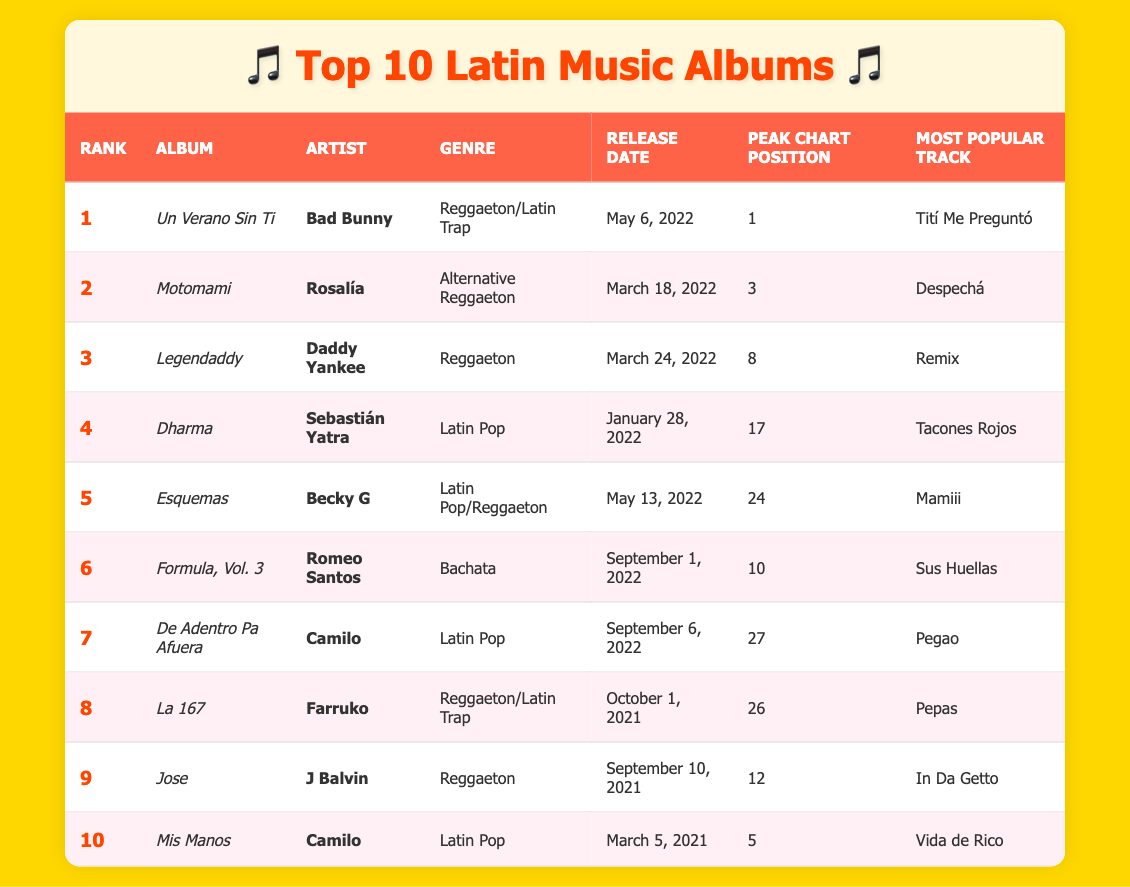What is the most popular track from "Un Verano Sin Ti"? The table indicates that the most popular track from the album "Un Verano Sin Ti" is "Tití Me Preguntó."
Answer: "Tití Me Preguntó" Which artist released the album "Motomami"? The table lists Rosalía as the artist who released the album "Motomami."
Answer: Rosalía How many albums peaked at position 1 in the chart? By looking through the "Peak Chart Position" column, we find that only one album, "Un Verano Sin Ti," peaked at position 1.
Answer: 1 What is the average peak chart position of the albums listed? The peak chart positions are 1, 3, 8, 17, 24, 10, 27, 26, 12, and 5. Adding these gives a total of 1 + 3 + 8 + 17 + 24 + 10 + 27 + 26 + 12 + 5 = 133. Dividing by the number of albums (10) gives 133/10 = 13.3.
Answer: 13.3 Is "Despechá" the most popular track for any other album besides "Motomami"? By checking the "Most Popular Track" column, we see that "Despechá" is only listed under "Motomami," confirming it is not the most popular track for any other album.
Answer: No Which album has the latest release date? The latest release dates to check are May 6, 2022, for "Un Verano Sin Ti" and September 1, 2022, for "Formula, Vol. 3." Comparing these, "Formula, Vol. 3" has the latest release date of September 1, 2022.
Answer: Formula, Vol. 3 What is the total number of Reggaeton albums in this list? Looking through the "Genre" column, we count three albums labeled as Reggaeton: "Un Verano Sin Ti," "Legendaddy," and "Jose."
Answer: 3 Which album is the lowest-ranked and what is its peak chart position? The table shows that the lowest-ranked album is "De Adentro Pa Afuera," which is at rank 7, and its peak chart position is 27.
Answer: 27 